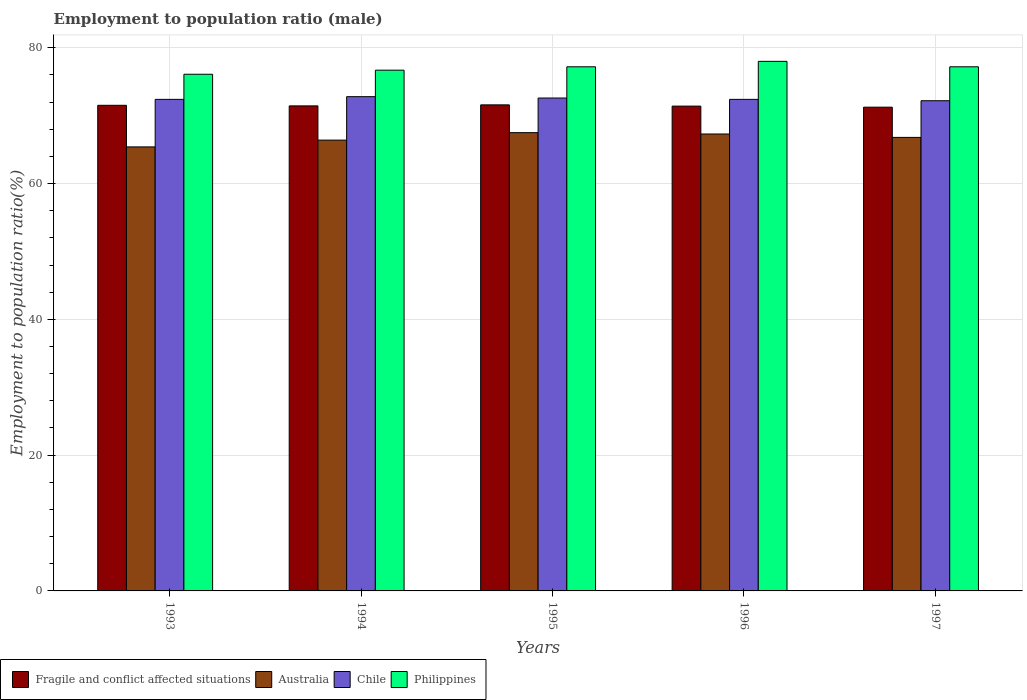How many groups of bars are there?
Your response must be concise. 5. How many bars are there on the 4th tick from the left?
Offer a very short reply. 4. How many bars are there on the 1st tick from the right?
Ensure brevity in your answer.  4. What is the label of the 3rd group of bars from the left?
Your answer should be compact. 1995. In how many cases, is the number of bars for a given year not equal to the number of legend labels?
Provide a short and direct response. 0. What is the employment to population ratio in Philippines in 1997?
Provide a short and direct response. 77.2. Across all years, what is the maximum employment to population ratio in Fragile and conflict affected situations?
Your response must be concise. 71.59. Across all years, what is the minimum employment to population ratio in Philippines?
Keep it short and to the point. 76.1. In which year was the employment to population ratio in Fragile and conflict affected situations maximum?
Provide a short and direct response. 1995. What is the total employment to population ratio in Chile in the graph?
Your answer should be very brief. 362.4. What is the difference between the employment to population ratio in Fragile and conflict affected situations in 1994 and that in 1997?
Offer a very short reply. 0.19. What is the difference between the employment to population ratio in Fragile and conflict affected situations in 1997 and the employment to population ratio in Chile in 1994?
Provide a succinct answer. -1.55. What is the average employment to population ratio in Australia per year?
Offer a terse response. 66.68. In the year 1996, what is the difference between the employment to population ratio in Australia and employment to population ratio in Philippines?
Provide a succinct answer. -10.7. What is the ratio of the employment to population ratio in Australia in 1995 to that in 1996?
Provide a short and direct response. 1. Is the difference between the employment to population ratio in Australia in 1993 and 1994 greater than the difference between the employment to population ratio in Philippines in 1993 and 1994?
Give a very brief answer. No. What is the difference between the highest and the second highest employment to population ratio in Australia?
Offer a very short reply. 0.2. What is the difference between the highest and the lowest employment to population ratio in Australia?
Offer a very short reply. 2.1. Is it the case that in every year, the sum of the employment to population ratio in Chile and employment to population ratio in Fragile and conflict affected situations is greater than the sum of employment to population ratio in Philippines and employment to population ratio in Australia?
Your answer should be compact. No. What does the 4th bar from the left in 1995 represents?
Provide a succinct answer. Philippines. What does the 4th bar from the right in 1997 represents?
Offer a terse response. Fragile and conflict affected situations. Are all the bars in the graph horizontal?
Give a very brief answer. No. How many years are there in the graph?
Your answer should be compact. 5. What is the difference between two consecutive major ticks on the Y-axis?
Your answer should be very brief. 20. Are the values on the major ticks of Y-axis written in scientific E-notation?
Provide a short and direct response. No. Does the graph contain any zero values?
Offer a very short reply. No. Does the graph contain grids?
Ensure brevity in your answer.  Yes. What is the title of the graph?
Your answer should be very brief. Employment to population ratio (male). What is the label or title of the X-axis?
Your answer should be compact. Years. What is the label or title of the Y-axis?
Give a very brief answer. Employment to population ratio(%). What is the Employment to population ratio(%) in Fragile and conflict affected situations in 1993?
Provide a short and direct response. 71.53. What is the Employment to population ratio(%) of Australia in 1993?
Provide a short and direct response. 65.4. What is the Employment to population ratio(%) in Chile in 1993?
Ensure brevity in your answer.  72.4. What is the Employment to population ratio(%) of Philippines in 1993?
Your answer should be compact. 76.1. What is the Employment to population ratio(%) in Fragile and conflict affected situations in 1994?
Make the answer very short. 71.44. What is the Employment to population ratio(%) of Australia in 1994?
Give a very brief answer. 66.4. What is the Employment to population ratio(%) in Chile in 1994?
Your response must be concise. 72.8. What is the Employment to population ratio(%) in Philippines in 1994?
Your answer should be compact. 76.7. What is the Employment to population ratio(%) of Fragile and conflict affected situations in 1995?
Your answer should be very brief. 71.59. What is the Employment to population ratio(%) of Australia in 1995?
Provide a short and direct response. 67.5. What is the Employment to population ratio(%) of Chile in 1995?
Keep it short and to the point. 72.6. What is the Employment to population ratio(%) in Philippines in 1995?
Your answer should be compact. 77.2. What is the Employment to population ratio(%) of Fragile and conflict affected situations in 1996?
Your answer should be very brief. 71.41. What is the Employment to population ratio(%) of Australia in 1996?
Ensure brevity in your answer.  67.3. What is the Employment to population ratio(%) of Chile in 1996?
Ensure brevity in your answer.  72.4. What is the Employment to population ratio(%) of Fragile and conflict affected situations in 1997?
Your response must be concise. 71.25. What is the Employment to population ratio(%) in Australia in 1997?
Make the answer very short. 66.8. What is the Employment to population ratio(%) in Chile in 1997?
Give a very brief answer. 72.2. What is the Employment to population ratio(%) in Philippines in 1997?
Ensure brevity in your answer.  77.2. Across all years, what is the maximum Employment to population ratio(%) in Fragile and conflict affected situations?
Offer a very short reply. 71.59. Across all years, what is the maximum Employment to population ratio(%) of Australia?
Your answer should be compact. 67.5. Across all years, what is the maximum Employment to population ratio(%) in Chile?
Keep it short and to the point. 72.8. Across all years, what is the minimum Employment to population ratio(%) in Fragile and conflict affected situations?
Your response must be concise. 71.25. Across all years, what is the minimum Employment to population ratio(%) of Australia?
Ensure brevity in your answer.  65.4. Across all years, what is the minimum Employment to population ratio(%) in Chile?
Offer a very short reply. 72.2. Across all years, what is the minimum Employment to population ratio(%) in Philippines?
Provide a succinct answer. 76.1. What is the total Employment to population ratio(%) of Fragile and conflict affected situations in the graph?
Your answer should be compact. 357.22. What is the total Employment to population ratio(%) in Australia in the graph?
Provide a succinct answer. 333.4. What is the total Employment to population ratio(%) in Chile in the graph?
Your answer should be very brief. 362.4. What is the total Employment to population ratio(%) in Philippines in the graph?
Ensure brevity in your answer.  385.2. What is the difference between the Employment to population ratio(%) in Fragile and conflict affected situations in 1993 and that in 1994?
Offer a terse response. 0.09. What is the difference between the Employment to population ratio(%) of Australia in 1993 and that in 1994?
Your answer should be very brief. -1. What is the difference between the Employment to population ratio(%) of Fragile and conflict affected situations in 1993 and that in 1995?
Keep it short and to the point. -0.06. What is the difference between the Employment to population ratio(%) of Australia in 1993 and that in 1995?
Your answer should be compact. -2.1. What is the difference between the Employment to population ratio(%) of Chile in 1993 and that in 1995?
Keep it short and to the point. -0.2. What is the difference between the Employment to population ratio(%) of Philippines in 1993 and that in 1995?
Offer a very short reply. -1.1. What is the difference between the Employment to population ratio(%) of Fragile and conflict affected situations in 1993 and that in 1996?
Keep it short and to the point. 0.12. What is the difference between the Employment to population ratio(%) in Australia in 1993 and that in 1996?
Give a very brief answer. -1.9. What is the difference between the Employment to population ratio(%) of Chile in 1993 and that in 1996?
Ensure brevity in your answer.  0. What is the difference between the Employment to population ratio(%) in Fragile and conflict affected situations in 1993 and that in 1997?
Keep it short and to the point. 0.28. What is the difference between the Employment to population ratio(%) of Australia in 1993 and that in 1997?
Your answer should be compact. -1.4. What is the difference between the Employment to population ratio(%) of Fragile and conflict affected situations in 1994 and that in 1995?
Ensure brevity in your answer.  -0.15. What is the difference between the Employment to population ratio(%) in Chile in 1994 and that in 1995?
Offer a terse response. 0.2. What is the difference between the Employment to population ratio(%) in Philippines in 1994 and that in 1995?
Make the answer very short. -0.5. What is the difference between the Employment to population ratio(%) in Fragile and conflict affected situations in 1994 and that in 1996?
Your answer should be very brief. 0.03. What is the difference between the Employment to population ratio(%) of Chile in 1994 and that in 1996?
Keep it short and to the point. 0.4. What is the difference between the Employment to population ratio(%) of Philippines in 1994 and that in 1996?
Keep it short and to the point. -1.3. What is the difference between the Employment to population ratio(%) in Fragile and conflict affected situations in 1994 and that in 1997?
Your answer should be very brief. 0.19. What is the difference between the Employment to population ratio(%) of Philippines in 1994 and that in 1997?
Provide a short and direct response. -0.5. What is the difference between the Employment to population ratio(%) of Fragile and conflict affected situations in 1995 and that in 1996?
Provide a short and direct response. 0.18. What is the difference between the Employment to population ratio(%) in Australia in 1995 and that in 1996?
Make the answer very short. 0.2. What is the difference between the Employment to population ratio(%) in Fragile and conflict affected situations in 1995 and that in 1997?
Your answer should be compact. 0.34. What is the difference between the Employment to population ratio(%) of Fragile and conflict affected situations in 1996 and that in 1997?
Offer a very short reply. 0.16. What is the difference between the Employment to population ratio(%) of Chile in 1996 and that in 1997?
Provide a short and direct response. 0.2. What is the difference between the Employment to population ratio(%) in Philippines in 1996 and that in 1997?
Give a very brief answer. 0.8. What is the difference between the Employment to population ratio(%) in Fragile and conflict affected situations in 1993 and the Employment to population ratio(%) in Australia in 1994?
Make the answer very short. 5.13. What is the difference between the Employment to population ratio(%) in Fragile and conflict affected situations in 1993 and the Employment to population ratio(%) in Chile in 1994?
Offer a terse response. -1.27. What is the difference between the Employment to population ratio(%) in Fragile and conflict affected situations in 1993 and the Employment to population ratio(%) in Philippines in 1994?
Make the answer very short. -5.17. What is the difference between the Employment to population ratio(%) of Australia in 1993 and the Employment to population ratio(%) of Chile in 1994?
Your answer should be compact. -7.4. What is the difference between the Employment to population ratio(%) of Australia in 1993 and the Employment to population ratio(%) of Philippines in 1994?
Make the answer very short. -11.3. What is the difference between the Employment to population ratio(%) of Chile in 1993 and the Employment to population ratio(%) of Philippines in 1994?
Make the answer very short. -4.3. What is the difference between the Employment to population ratio(%) of Fragile and conflict affected situations in 1993 and the Employment to population ratio(%) of Australia in 1995?
Your answer should be very brief. 4.03. What is the difference between the Employment to population ratio(%) of Fragile and conflict affected situations in 1993 and the Employment to population ratio(%) of Chile in 1995?
Offer a terse response. -1.07. What is the difference between the Employment to population ratio(%) in Fragile and conflict affected situations in 1993 and the Employment to population ratio(%) in Philippines in 1995?
Ensure brevity in your answer.  -5.67. What is the difference between the Employment to population ratio(%) of Australia in 1993 and the Employment to population ratio(%) of Chile in 1995?
Your response must be concise. -7.2. What is the difference between the Employment to population ratio(%) of Fragile and conflict affected situations in 1993 and the Employment to population ratio(%) of Australia in 1996?
Your answer should be compact. 4.23. What is the difference between the Employment to population ratio(%) in Fragile and conflict affected situations in 1993 and the Employment to population ratio(%) in Chile in 1996?
Give a very brief answer. -0.87. What is the difference between the Employment to population ratio(%) in Fragile and conflict affected situations in 1993 and the Employment to population ratio(%) in Philippines in 1996?
Make the answer very short. -6.47. What is the difference between the Employment to population ratio(%) of Fragile and conflict affected situations in 1993 and the Employment to population ratio(%) of Australia in 1997?
Your answer should be compact. 4.73. What is the difference between the Employment to population ratio(%) of Fragile and conflict affected situations in 1993 and the Employment to population ratio(%) of Chile in 1997?
Provide a succinct answer. -0.67. What is the difference between the Employment to population ratio(%) of Fragile and conflict affected situations in 1993 and the Employment to population ratio(%) of Philippines in 1997?
Provide a succinct answer. -5.67. What is the difference between the Employment to population ratio(%) in Australia in 1993 and the Employment to population ratio(%) in Chile in 1997?
Your answer should be very brief. -6.8. What is the difference between the Employment to population ratio(%) of Australia in 1993 and the Employment to population ratio(%) of Philippines in 1997?
Provide a short and direct response. -11.8. What is the difference between the Employment to population ratio(%) in Chile in 1993 and the Employment to population ratio(%) in Philippines in 1997?
Provide a succinct answer. -4.8. What is the difference between the Employment to population ratio(%) of Fragile and conflict affected situations in 1994 and the Employment to population ratio(%) of Australia in 1995?
Provide a succinct answer. 3.94. What is the difference between the Employment to population ratio(%) of Fragile and conflict affected situations in 1994 and the Employment to population ratio(%) of Chile in 1995?
Offer a very short reply. -1.16. What is the difference between the Employment to population ratio(%) of Fragile and conflict affected situations in 1994 and the Employment to population ratio(%) of Philippines in 1995?
Offer a terse response. -5.76. What is the difference between the Employment to population ratio(%) in Australia in 1994 and the Employment to population ratio(%) in Chile in 1995?
Give a very brief answer. -6.2. What is the difference between the Employment to population ratio(%) in Chile in 1994 and the Employment to population ratio(%) in Philippines in 1995?
Your answer should be compact. -4.4. What is the difference between the Employment to population ratio(%) in Fragile and conflict affected situations in 1994 and the Employment to population ratio(%) in Australia in 1996?
Your answer should be very brief. 4.14. What is the difference between the Employment to population ratio(%) of Fragile and conflict affected situations in 1994 and the Employment to population ratio(%) of Chile in 1996?
Offer a terse response. -0.96. What is the difference between the Employment to population ratio(%) in Fragile and conflict affected situations in 1994 and the Employment to population ratio(%) in Philippines in 1996?
Offer a terse response. -6.56. What is the difference between the Employment to population ratio(%) in Australia in 1994 and the Employment to population ratio(%) in Philippines in 1996?
Provide a short and direct response. -11.6. What is the difference between the Employment to population ratio(%) in Chile in 1994 and the Employment to population ratio(%) in Philippines in 1996?
Offer a terse response. -5.2. What is the difference between the Employment to population ratio(%) in Fragile and conflict affected situations in 1994 and the Employment to population ratio(%) in Australia in 1997?
Your answer should be very brief. 4.64. What is the difference between the Employment to population ratio(%) in Fragile and conflict affected situations in 1994 and the Employment to population ratio(%) in Chile in 1997?
Your response must be concise. -0.76. What is the difference between the Employment to population ratio(%) of Fragile and conflict affected situations in 1994 and the Employment to population ratio(%) of Philippines in 1997?
Provide a short and direct response. -5.76. What is the difference between the Employment to population ratio(%) in Australia in 1994 and the Employment to population ratio(%) in Chile in 1997?
Ensure brevity in your answer.  -5.8. What is the difference between the Employment to population ratio(%) in Australia in 1994 and the Employment to population ratio(%) in Philippines in 1997?
Your answer should be compact. -10.8. What is the difference between the Employment to population ratio(%) of Chile in 1994 and the Employment to population ratio(%) of Philippines in 1997?
Offer a very short reply. -4.4. What is the difference between the Employment to population ratio(%) of Fragile and conflict affected situations in 1995 and the Employment to population ratio(%) of Australia in 1996?
Offer a terse response. 4.29. What is the difference between the Employment to population ratio(%) in Fragile and conflict affected situations in 1995 and the Employment to population ratio(%) in Chile in 1996?
Offer a terse response. -0.81. What is the difference between the Employment to population ratio(%) in Fragile and conflict affected situations in 1995 and the Employment to population ratio(%) in Philippines in 1996?
Your response must be concise. -6.41. What is the difference between the Employment to population ratio(%) in Fragile and conflict affected situations in 1995 and the Employment to population ratio(%) in Australia in 1997?
Ensure brevity in your answer.  4.79. What is the difference between the Employment to population ratio(%) of Fragile and conflict affected situations in 1995 and the Employment to population ratio(%) of Chile in 1997?
Your answer should be very brief. -0.61. What is the difference between the Employment to population ratio(%) in Fragile and conflict affected situations in 1995 and the Employment to population ratio(%) in Philippines in 1997?
Your answer should be very brief. -5.61. What is the difference between the Employment to population ratio(%) in Australia in 1995 and the Employment to population ratio(%) in Chile in 1997?
Your answer should be very brief. -4.7. What is the difference between the Employment to population ratio(%) of Australia in 1995 and the Employment to population ratio(%) of Philippines in 1997?
Ensure brevity in your answer.  -9.7. What is the difference between the Employment to population ratio(%) of Fragile and conflict affected situations in 1996 and the Employment to population ratio(%) of Australia in 1997?
Give a very brief answer. 4.61. What is the difference between the Employment to population ratio(%) of Fragile and conflict affected situations in 1996 and the Employment to population ratio(%) of Chile in 1997?
Offer a very short reply. -0.79. What is the difference between the Employment to population ratio(%) in Fragile and conflict affected situations in 1996 and the Employment to population ratio(%) in Philippines in 1997?
Give a very brief answer. -5.79. What is the difference between the Employment to population ratio(%) in Australia in 1996 and the Employment to population ratio(%) in Chile in 1997?
Your response must be concise. -4.9. What is the difference between the Employment to population ratio(%) in Australia in 1996 and the Employment to population ratio(%) in Philippines in 1997?
Make the answer very short. -9.9. What is the average Employment to population ratio(%) of Fragile and conflict affected situations per year?
Provide a short and direct response. 71.44. What is the average Employment to population ratio(%) of Australia per year?
Your response must be concise. 66.68. What is the average Employment to population ratio(%) in Chile per year?
Your answer should be very brief. 72.48. What is the average Employment to population ratio(%) in Philippines per year?
Your answer should be compact. 77.04. In the year 1993, what is the difference between the Employment to population ratio(%) in Fragile and conflict affected situations and Employment to population ratio(%) in Australia?
Make the answer very short. 6.13. In the year 1993, what is the difference between the Employment to population ratio(%) in Fragile and conflict affected situations and Employment to population ratio(%) in Chile?
Offer a very short reply. -0.87. In the year 1993, what is the difference between the Employment to population ratio(%) of Fragile and conflict affected situations and Employment to population ratio(%) of Philippines?
Make the answer very short. -4.57. In the year 1993, what is the difference between the Employment to population ratio(%) of Australia and Employment to population ratio(%) of Chile?
Your response must be concise. -7. In the year 1993, what is the difference between the Employment to population ratio(%) of Australia and Employment to population ratio(%) of Philippines?
Your answer should be compact. -10.7. In the year 1993, what is the difference between the Employment to population ratio(%) in Chile and Employment to population ratio(%) in Philippines?
Give a very brief answer. -3.7. In the year 1994, what is the difference between the Employment to population ratio(%) of Fragile and conflict affected situations and Employment to population ratio(%) of Australia?
Your response must be concise. 5.04. In the year 1994, what is the difference between the Employment to population ratio(%) of Fragile and conflict affected situations and Employment to population ratio(%) of Chile?
Provide a succinct answer. -1.36. In the year 1994, what is the difference between the Employment to population ratio(%) in Fragile and conflict affected situations and Employment to population ratio(%) in Philippines?
Keep it short and to the point. -5.26. In the year 1994, what is the difference between the Employment to population ratio(%) in Australia and Employment to population ratio(%) in Chile?
Give a very brief answer. -6.4. In the year 1994, what is the difference between the Employment to population ratio(%) in Australia and Employment to population ratio(%) in Philippines?
Make the answer very short. -10.3. In the year 1995, what is the difference between the Employment to population ratio(%) of Fragile and conflict affected situations and Employment to population ratio(%) of Australia?
Your answer should be compact. 4.09. In the year 1995, what is the difference between the Employment to population ratio(%) of Fragile and conflict affected situations and Employment to population ratio(%) of Chile?
Your answer should be very brief. -1.01. In the year 1995, what is the difference between the Employment to population ratio(%) in Fragile and conflict affected situations and Employment to population ratio(%) in Philippines?
Give a very brief answer. -5.61. In the year 1996, what is the difference between the Employment to population ratio(%) in Fragile and conflict affected situations and Employment to population ratio(%) in Australia?
Ensure brevity in your answer.  4.11. In the year 1996, what is the difference between the Employment to population ratio(%) of Fragile and conflict affected situations and Employment to population ratio(%) of Chile?
Provide a short and direct response. -0.99. In the year 1996, what is the difference between the Employment to population ratio(%) in Fragile and conflict affected situations and Employment to population ratio(%) in Philippines?
Offer a very short reply. -6.59. In the year 1996, what is the difference between the Employment to population ratio(%) in Australia and Employment to population ratio(%) in Chile?
Provide a succinct answer. -5.1. In the year 1997, what is the difference between the Employment to population ratio(%) in Fragile and conflict affected situations and Employment to population ratio(%) in Australia?
Your response must be concise. 4.45. In the year 1997, what is the difference between the Employment to population ratio(%) in Fragile and conflict affected situations and Employment to population ratio(%) in Chile?
Your response must be concise. -0.95. In the year 1997, what is the difference between the Employment to population ratio(%) in Fragile and conflict affected situations and Employment to population ratio(%) in Philippines?
Your answer should be compact. -5.95. In the year 1997, what is the difference between the Employment to population ratio(%) in Australia and Employment to population ratio(%) in Chile?
Give a very brief answer. -5.4. In the year 1997, what is the difference between the Employment to population ratio(%) of Chile and Employment to population ratio(%) of Philippines?
Provide a succinct answer. -5. What is the ratio of the Employment to population ratio(%) of Fragile and conflict affected situations in 1993 to that in 1994?
Provide a short and direct response. 1. What is the ratio of the Employment to population ratio(%) of Australia in 1993 to that in 1994?
Make the answer very short. 0.98. What is the ratio of the Employment to population ratio(%) in Chile in 1993 to that in 1994?
Offer a very short reply. 0.99. What is the ratio of the Employment to population ratio(%) in Fragile and conflict affected situations in 1993 to that in 1995?
Provide a short and direct response. 1. What is the ratio of the Employment to population ratio(%) in Australia in 1993 to that in 1995?
Ensure brevity in your answer.  0.97. What is the ratio of the Employment to population ratio(%) in Chile in 1993 to that in 1995?
Offer a terse response. 1. What is the ratio of the Employment to population ratio(%) in Philippines in 1993 to that in 1995?
Your response must be concise. 0.99. What is the ratio of the Employment to population ratio(%) in Australia in 1993 to that in 1996?
Provide a short and direct response. 0.97. What is the ratio of the Employment to population ratio(%) of Chile in 1993 to that in 1996?
Your answer should be very brief. 1. What is the ratio of the Employment to population ratio(%) in Philippines in 1993 to that in 1996?
Your answer should be compact. 0.98. What is the ratio of the Employment to population ratio(%) of Fragile and conflict affected situations in 1993 to that in 1997?
Ensure brevity in your answer.  1. What is the ratio of the Employment to population ratio(%) of Australia in 1993 to that in 1997?
Your response must be concise. 0.98. What is the ratio of the Employment to population ratio(%) of Chile in 1993 to that in 1997?
Your answer should be very brief. 1. What is the ratio of the Employment to population ratio(%) of Philippines in 1993 to that in 1997?
Your answer should be compact. 0.99. What is the ratio of the Employment to population ratio(%) in Fragile and conflict affected situations in 1994 to that in 1995?
Offer a very short reply. 1. What is the ratio of the Employment to population ratio(%) in Australia in 1994 to that in 1995?
Provide a succinct answer. 0.98. What is the ratio of the Employment to population ratio(%) of Chile in 1994 to that in 1995?
Ensure brevity in your answer.  1. What is the ratio of the Employment to population ratio(%) of Philippines in 1994 to that in 1995?
Provide a succinct answer. 0.99. What is the ratio of the Employment to population ratio(%) of Fragile and conflict affected situations in 1994 to that in 1996?
Ensure brevity in your answer.  1. What is the ratio of the Employment to population ratio(%) of Australia in 1994 to that in 1996?
Offer a very short reply. 0.99. What is the ratio of the Employment to population ratio(%) of Philippines in 1994 to that in 1996?
Provide a succinct answer. 0.98. What is the ratio of the Employment to population ratio(%) in Fragile and conflict affected situations in 1994 to that in 1997?
Provide a short and direct response. 1. What is the ratio of the Employment to population ratio(%) of Chile in 1994 to that in 1997?
Your answer should be very brief. 1.01. What is the ratio of the Employment to population ratio(%) in Philippines in 1994 to that in 1997?
Ensure brevity in your answer.  0.99. What is the ratio of the Employment to population ratio(%) of Fragile and conflict affected situations in 1995 to that in 1996?
Your response must be concise. 1. What is the ratio of the Employment to population ratio(%) in Australia in 1995 to that in 1996?
Your response must be concise. 1. What is the ratio of the Employment to population ratio(%) of Australia in 1995 to that in 1997?
Your response must be concise. 1.01. What is the ratio of the Employment to population ratio(%) of Fragile and conflict affected situations in 1996 to that in 1997?
Offer a very short reply. 1. What is the ratio of the Employment to population ratio(%) in Australia in 1996 to that in 1997?
Give a very brief answer. 1.01. What is the ratio of the Employment to population ratio(%) of Chile in 1996 to that in 1997?
Make the answer very short. 1. What is the ratio of the Employment to population ratio(%) in Philippines in 1996 to that in 1997?
Provide a succinct answer. 1.01. What is the difference between the highest and the second highest Employment to population ratio(%) of Fragile and conflict affected situations?
Provide a succinct answer. 0.06. What is the difference between the highest and the second highest Employment to population ratio(%) in Chile?
Offer a very short reply. 0.2. What is the difference between the highest and the lowest Employment to population ratio(%) in Fragile and conflict affected situations?
Provide a succinct answer. 0.34. What is the difference between the highest and the lowest Employment to population ratio(%) in Philippines?
Provide a succinct answer. 1.9. 